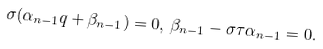Convert formula to latex. <formula><loc_0><loc_0><loc_500><loc_500>\sigma ( \alpha _ { n - 1 } q + \beta _ { n - 1 } ) = 0 , \, \beta _ { n - 1 } - \sigma \tau \alpha _ { n - 1 } = 0 .</formula> 